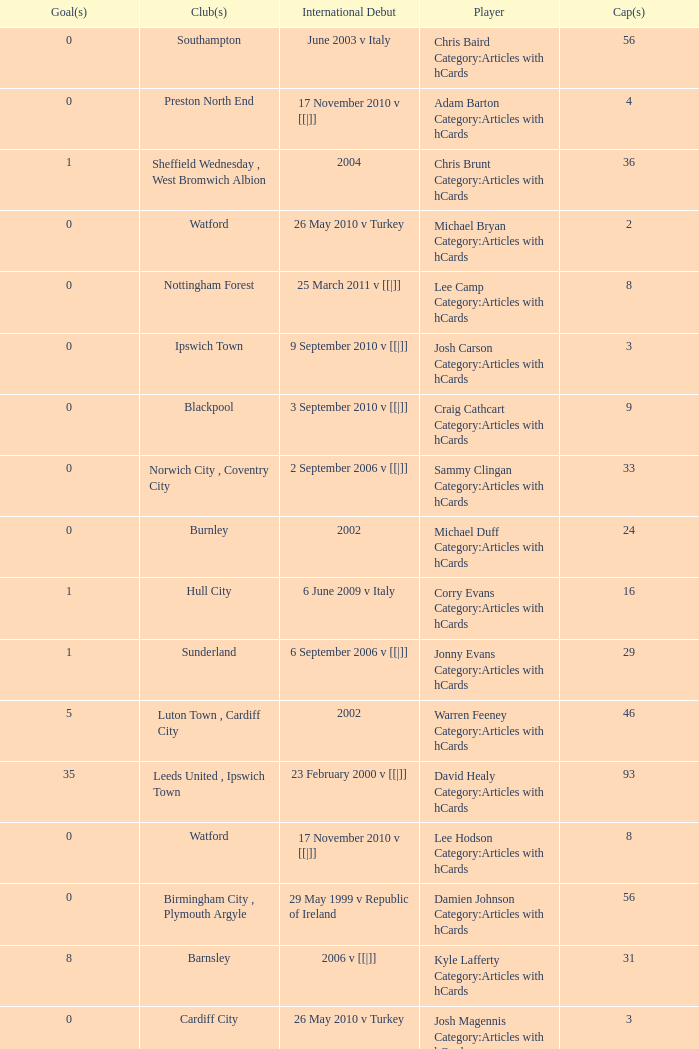How many caps figures are there for Norwich City, Coventry City? 1.0. 